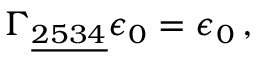Convert formula to latex. <formula><loc_0><loc_0><loc_500><loc_500>\Gamma _ { \underline { 2 5 3 4 } } \epsilon _ { 0 } = \epsilon _ { 0 } \, ,</formula> 